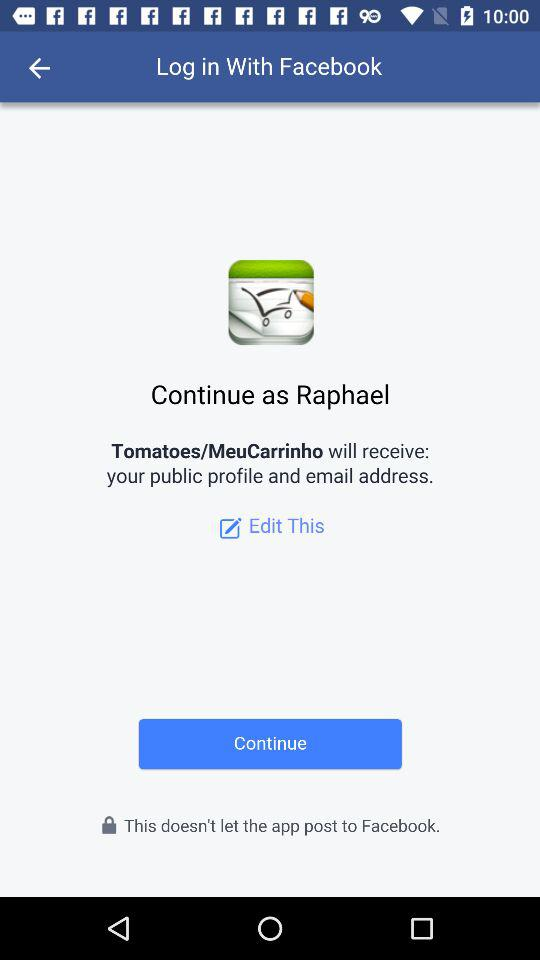What is the login name? The login name is Raphael. 